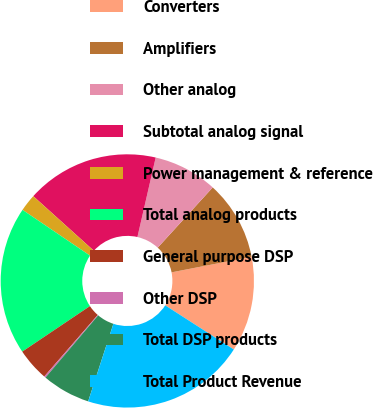Convert chart to OTSL. <chart><loc_0><loc_0><loc_500><loc_500><pie_chart><fcel>Converters<fcel>Amplifiers<fcel>Other analog<fcel>Subtotal analog signal<fcel>Power management & reference<fcel>Total analog products<fcel>General purpose DSP<fcel>Other DSP<fcel>Total DSP products<fcel>Total Product Revenue<nl><fcel>12.16%<fcel>10.17%<fcel>8.18%<fcel>16.92%<fcel>2.19%<fcel>18.91%<fcel>4.19%<fcel>0.2%<fcel>6.18%<fcel>20.9%<nl></chart> 